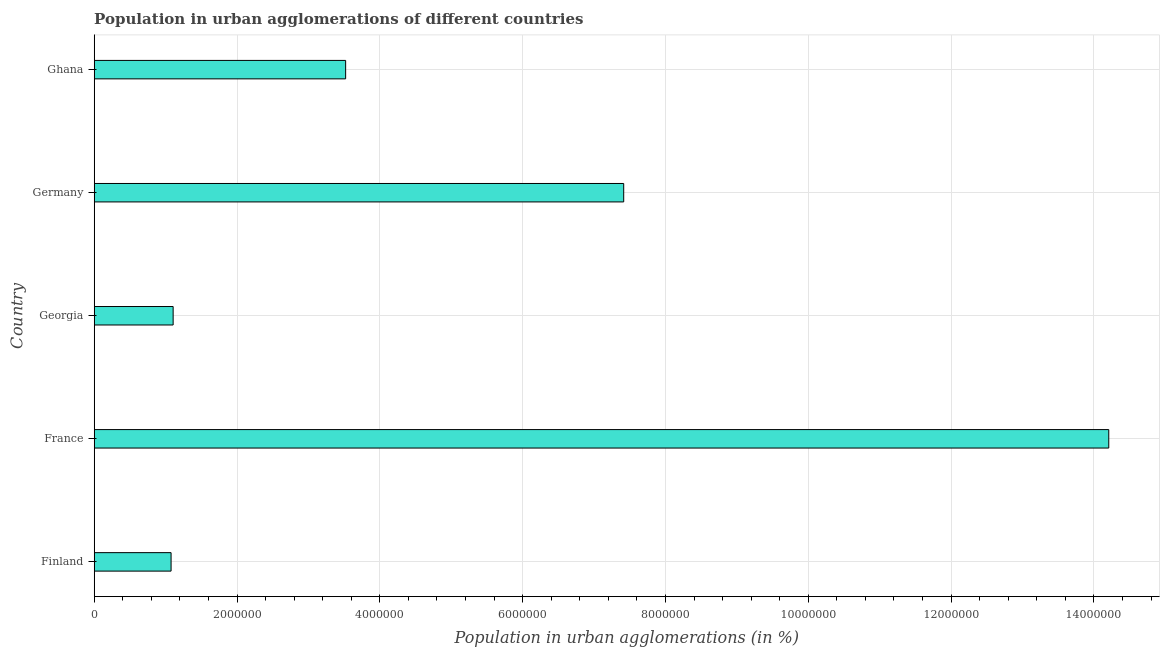Does the graph contain any zero values?
Keep it short and to the point. No. What is the title of the graph?
Provide a short and direct response. Population in urban agglomerations of different countries. What is the label or title of the X-axis?
Provide a succinct answer. Population in urban agglomerations (in %). What is the label or title of the Y-axis?
Provide a short and direct response. Country. What is the population in urban agglomerations in Finland?
Your response must be concise. 1.08e+06. Across all countries, what is the maximum population in urban agglomerations?
Keep it short and to the point. 1.42e+07. Across all countries, what is the minimum population in urban agglomerations?
Offer a terse response. 1.08e+06. In which country was the population in urban agglomerations maximum?
Offer a very short reply. France. In which country was the population in urban agglomerations minimum?
Ensure brevity in your answer.  Finland. What is the sum of the population in urban agglomerations?
Offer a terse response. 2.73e+07. What is the difference between the population in urban agglomerations in Germany and Ghana?
Offer a terse response. 3.89e+06. What is the average population in urban agglomerations per country?
Keep it short and to the point. 5.47e+06. What is the median population in urban agglomerations?
Your answer should be very brief. 3.52e+06. In how many countries, is the population in urban agglomerations greater than 14000000 %?
Make the answer very short. 1. What is the ratio of the population in urban agglomerations in Finland to that in Ghana?
Provide a succinct answer. 0.31. What is the difference between the highest and the second highest population in urban agglomerations?
Ensure brevity in your answer.  6.79e+06. What is the difference between the highest and the lowest population in urban agglomerations?
Ensure brevity in your answer.  1.31e+07. How many bars are there?
Ensure brevity in your answer.  5. Are all the bars in the graph horizontal?
Ensure brevity in your answer.  Yes. How many countries are there in the graph?
Provide a short and direct response. 5. What is the difference between two consecutive major ticks on the X-axis?
Provide a short and direct response. 2.00e+06. What is the Population in urban agglomerations (in %) in Finland?
Provide a short and direct response. 1.08e+06. What is the Population in urban agglomerations (in %) in France?
Your answer should be compact. 1.42e+07. What is the Population in urban agglomerations (in %) in Georgia?
Your response must be concise. 1.11e+06. What is the Population in urban agglomerations (in %) in Germany?
Give a very brief answer. 7.42e+06. What is the Population in urban agglomerations (in %) of Ghana?
Your answer should be very brief. 3.52e+06. What is the difference between the Population in urban agglomerations (in %) in Finland and France?
Your answer should be very brief. -1.31e+07. What is the difference between the Population in urban agglomerations (in %) in Finland and Georgia?
Your answer should be very brief. -2.89e+04. What is the difference between the Population in urban agglomerations (in %) in Finland and Germany?
Your answer should be compact. -6.34e+06. What is the difference between the Population in urban agglomerations (in %) in Finland and Ghana?
Keep it short and to the point. -2.44e+06. What is the difference between the Population in urban agglomerations (in %) in France and Georgia?
Your response must be concise. 1.31e+07. What is the difference between the Population in urban agglomerations (in %) in France and Germany?
Ensure brevity in your answer.  6.79e+06. What is the difference between the Population in urban agglomerations (in %) in France and Ghana?
Keep it short and to the point. 1.07e+07. What is the difference between the Population in urban agglomerations (in %) in Georgia and Germany?
Offer a terse response. -6.31e+06. What is the difference between the Population in urban agglomerations (in %) in Georgia and Ghana?
Offer a very short reply. -2.42e+06. What is the difference between the Population in urban agglomerations (in %) in Germany and Ghana?
Offer a very short reply. 3.89e+06. What is the ratio of the Population in urban agglomerations (in %) in Finland to that in France?
Keep it short and to the point. 0.08. What is the ratio of the Population in urban agglomerations (in %) in Finland to that in Georgia?
Offer a terse response. 0.97. What is the ratio of the Population in urban agglomerations (in %) in Finland to that in Germany?
Your response must be concise. 0.14. What is the ratio of the Population in urban agglomerations (in %) in Finland to that in Ghana?
Your response must be concise. 0.31. What is the ratio of the Population in urban agglomerations (in %) in France to that in Georgia?
Offer a terse response. 12.85. What is the ratio of the Population in urban agglomerations (in %) in France to that in Germany?
Make the answer very short. 1.92. What is the ratio of the Population in urban agglomerations (in %) in France to that in Ghana?
Ensure brevity in your answer.  4.04. What is the ratio of the Population in urban agglomerations (in %) in Georgia to that in Germany?
Ensure brevity in your answer.  0.15. What is the ratio of the Population in urban agglomerations (in %) in Georgia to that in Ghana?
Your answer should be very brief. 0.31. What is the ratio of the Population in urban agglomerations (in %) in Germany to that in Ghana?
Offer a very short reply. 2.11. 